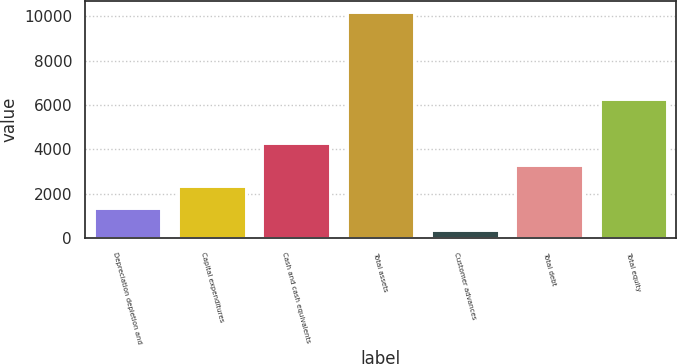Convert chart. <chart><loc_0><loc_0><loc_500><loc_500><bar_chart><fcel>Depreciation depletion and<fcel>Capital expenditures<fcel>Cash and cash equivalents<fcel>Total assets<fcel>Customer advances<fcel>Total debt<fcel>Total equity<nl><fcel>1359.32<fcel>2337.94<fcel>4295.18<fcel>10166.9<fcel>380.7<fcel>3316.56<fcel>6282.2<nl></chart> 